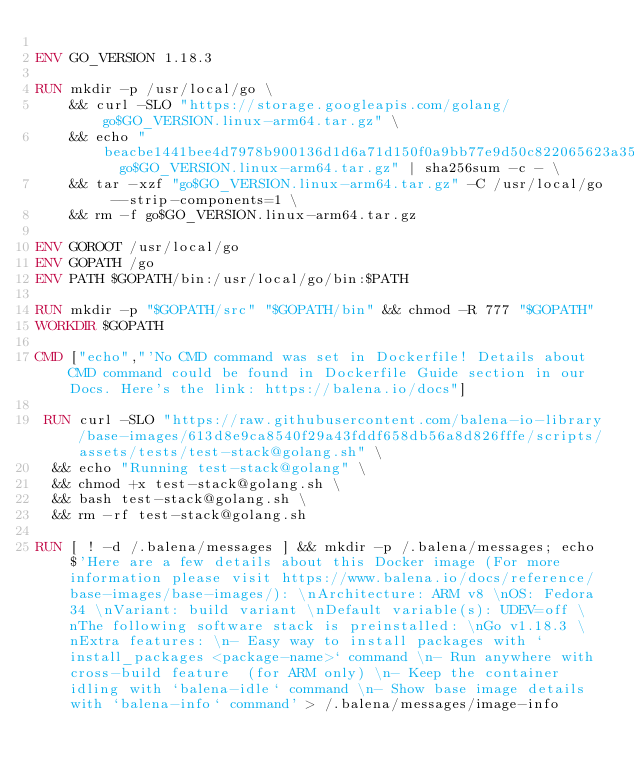<code> <loc_0><loc_0><loc_500><loc_500><_Dockerfile_>
ENV GO_VERSION 1.18.3

RUN mkdir -p /usr/local/go \
	&& curl -SLO "https://storage.googleapis.com/golang/go$GO_VERSION.linux-arm64.tar.gz" \
	&& echo "beacbe1441bee4d7978b900136d1d6a71d150f0a9bb77e9d50c822065623a35a  go$GO_VERSION.linux-arm64.tar.gz" | sha256sum -c - \
	&& tar -xzf "go$GO_VERSION.linux-arm64.tar.gz" -C /usr/local/go --strip-components=1 \
	&& rm -f go$GO_VERSION.linux-arm64.tar.gz

ENV GOROOT /usr/local/go
ENV GOPATH /go
ENV PATH $GOPATH/bin:/usr/local/go/bin:$PATH

RUN mkdir -p "$GOPATH/src" "$GOPATH/bin" && chmod -R 777 "$GOPATH"
WORKDIR $GOPATH

CMD ["echo","'No CMD command was set in Dockerfile! Details about CMD command could be found in Dockerfile Guide section in our Docs. Here's the link: https://balena.io/docs"]

 RUN curl -SLO "https://raw.githubusercontent.com/balena-io-library/base-images/613d8e9ca8540f29a43fddf658db56a8d826fffe/scripts/assets/tests/test-stack@golang.sh" \
  && echo "Running test-stack@golang" \
  && chmod +x test-stack@golang.sh \
  && bash test-stack@golang.sh \
  && rm -rf test-stack@golang.sh 

RUN [ ! -d /.balena/messages ] && mkdir -p /.balena/messages; echo $'Here are a few details about this Docker image (For more information please visit https://www.balena.io/docs/reference/base-images/base-images/): \nArchitecture: ARM v8 \nOS: Fedora 34 \nVariant: build variant \nDefault variable(s): UDEV=off \nThe following software stack is preinstalled: \nGo v1.18.3 \nExtra features: \n- Easy way to install packages with `install_packages <package-name>` command \n- Run anywhere with cross-build feature  (for ARM only) \n- Keep the container idling with `balena-idle` command \n- Show base image details with `balena-info` command' > /.balena/messages/image-info</code> 